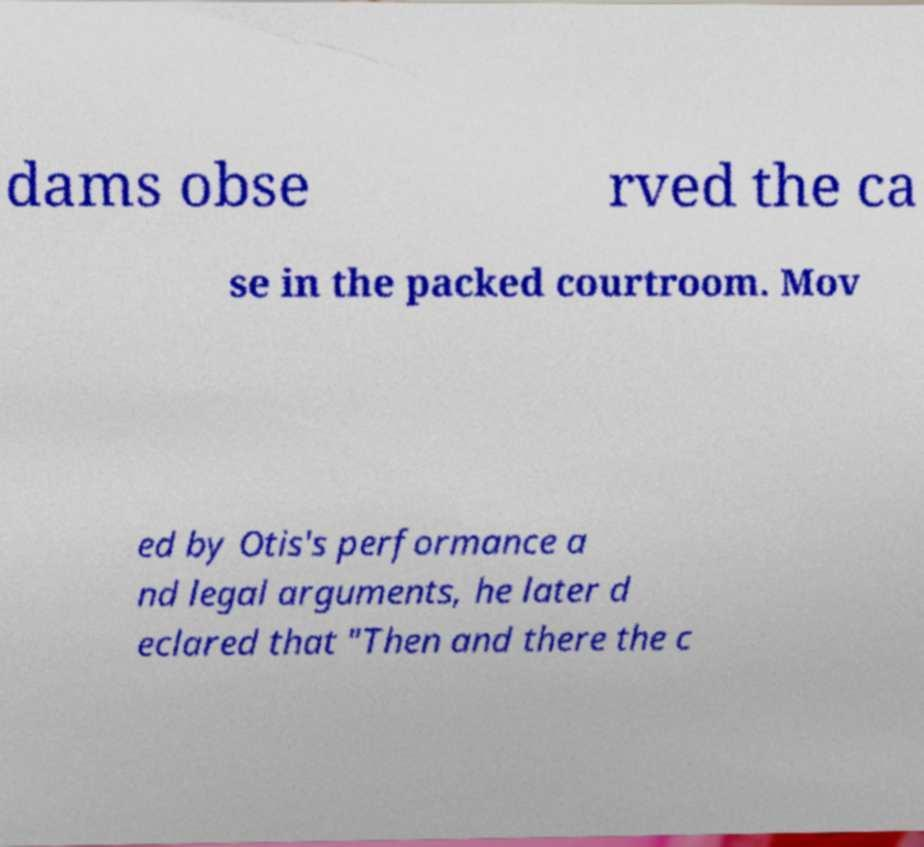Could you assist in decoding the text presented in this image and type it out clearly? dams obse rved the ca se in the packed courtroom. Mov ed by Otis's performance a nd legal arguments, he later d eclared that "Then and there the c 